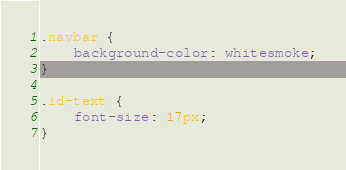<code> <loc_0><loc_0><loc_500><loc_500><_CSS_>.navbar {
    background-color: whitesmoke;
}

.id-text {
    font-size: 17px;
}</code> 